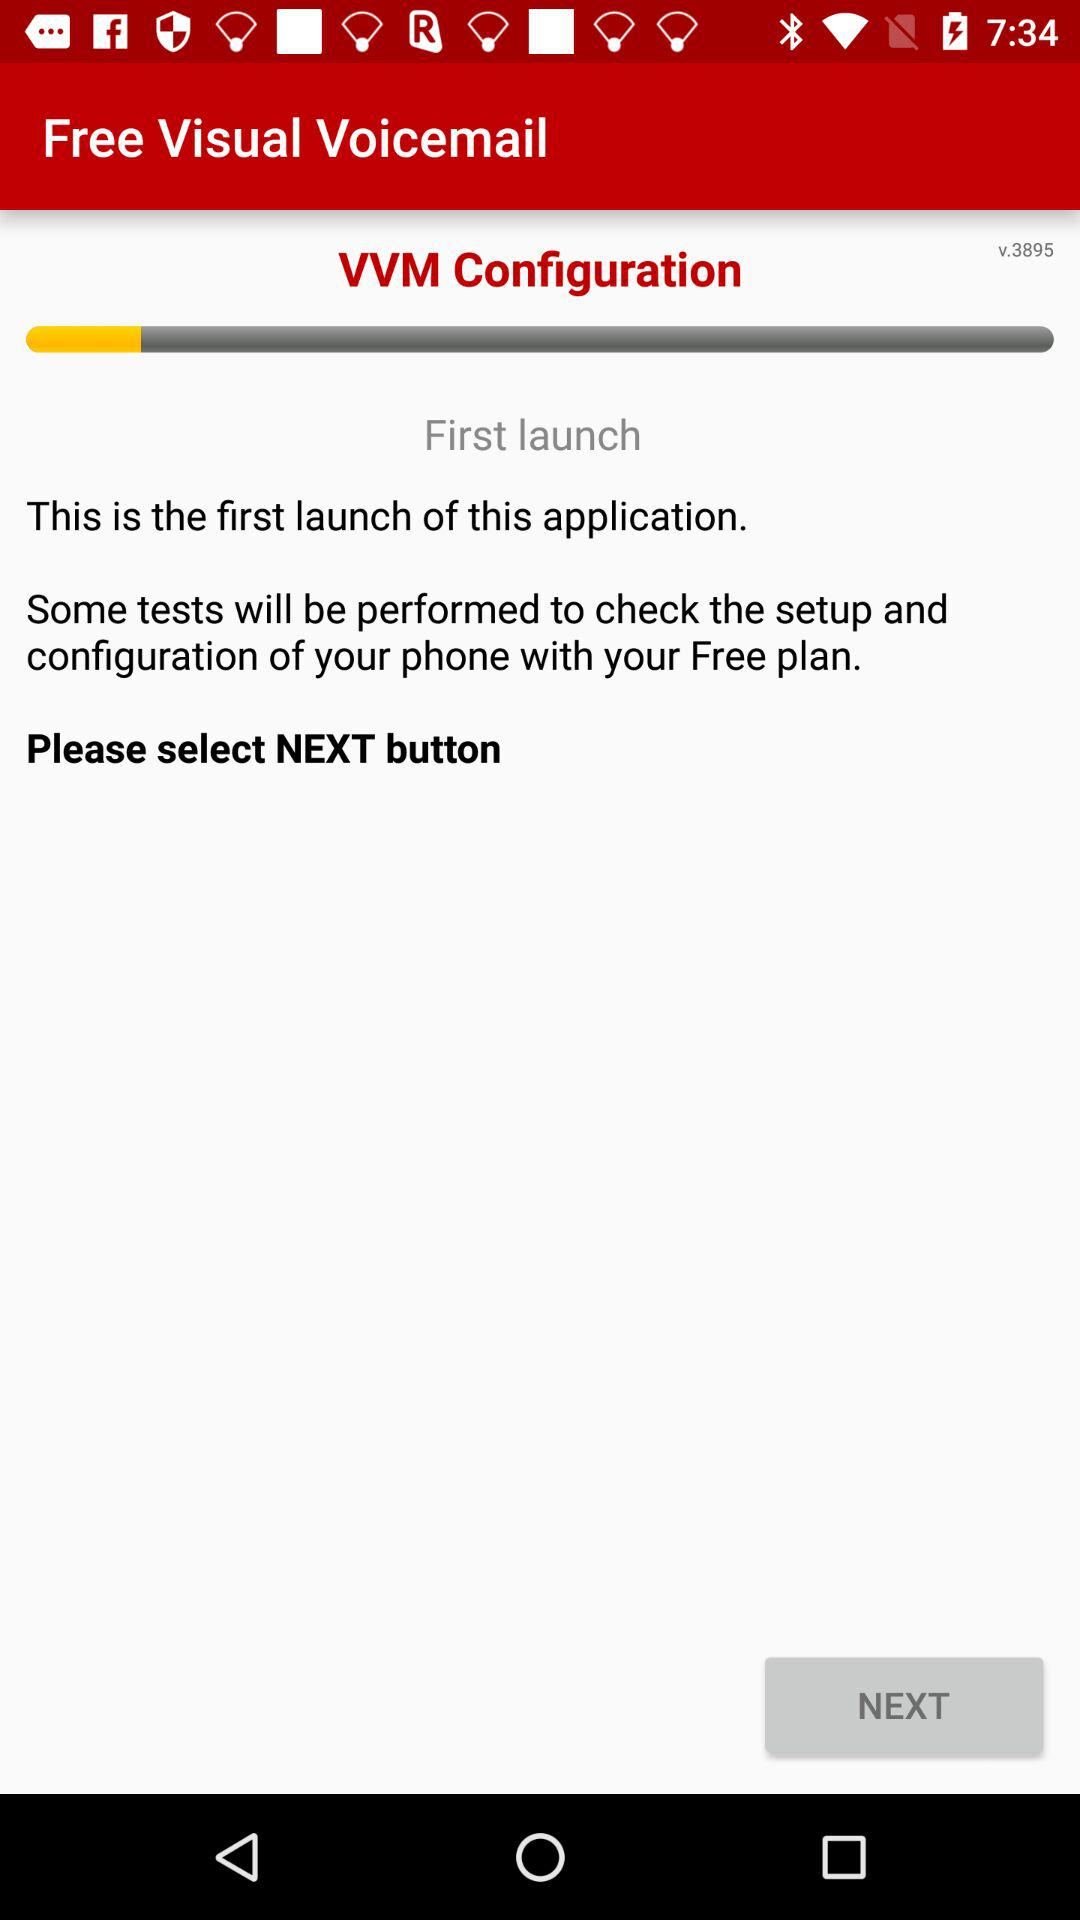What is the application name? The application name is "Free Visual Voicemail". 